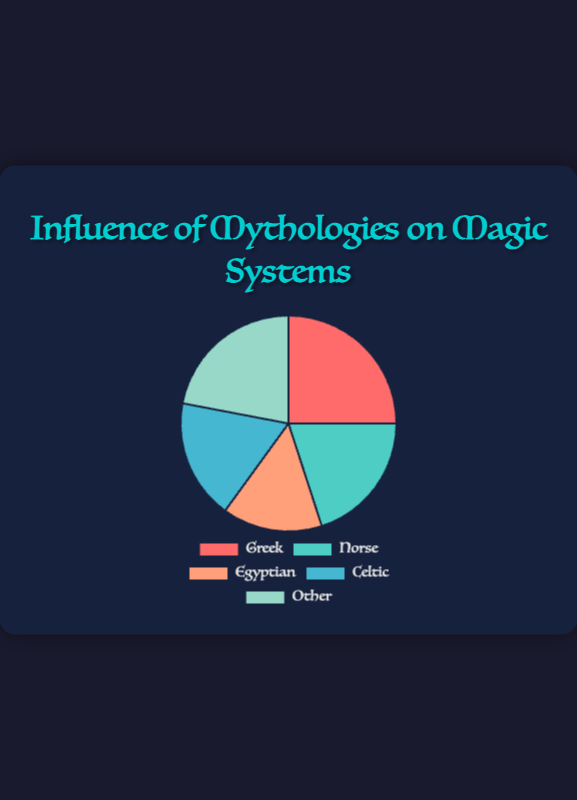What is the most influential mythology on popular magic systems according to the pie chart? The pie chart shows five mythologies with their percentage influence. Greek mythology has the highest influence at 25%.
Answer: Greek Which mythology has the least influence on popular magic systems? The pie chart displays five mythologies with their influence percentages. Egyptian mythology has the lowest percentage at 15%.
Answer: Egyptian How much more influential is Greek mythology compared to Norse mythology? The influence of Greek mythology is 25%, and the influence of Norse mythology is 20%. Calculate the difference: 25% - 20% = 5%.
Answer: 5% What is the total percentage of influence by Celtic and Egyptian mythologies combined? Celtic mythology has an influence of 18%, and Egyptian mythology has 15%. Sum these values: 18% + 15% = 33%.
Answer: 33% Which two mythologies have a combined influence closest to one-third of the total influence? One-third of 100% is approximately 33%. The combined influence of Celtic (18%) and Egyptian (15%) is 33%.
Answer: Celtic and Egyptian How does the influence of "Other" mythologies compare to that of Celtic mythology? "Other" mythologies have an influence of 22%, while Celtic mythology has 18%. The difference is 22% - 18% = 4%.
Answer: 4% What are the influences of mythologies that have less than 20% influence each? The categories with less than 20% influence are Norse (20%) and Egyptian (15%).
Answer: Norse and Egyptian Which mythology's influence, according to the pie chart, falls between the influences of Celtic and "Other" mythologies? Celtic mythology's influence is 18%, and "Other" has 22%. Norse mythology's influence of 20% falls between these two values.
Answer: Norse What percentage difference separates the "Other" mythologies from the most influential mythology? The "Other" mythologies have an influence of 22%, and the Greek mythology influence is 25%. The difference is 25% - 22% = 3%.
Answer: 3% How does the red section of the pie chart compare in size to the green section? The red section represents Greek mythology with 25% influence, and the green section represents Norse with 20% influence. The red section is larger by 5%.
Answer: 5% 